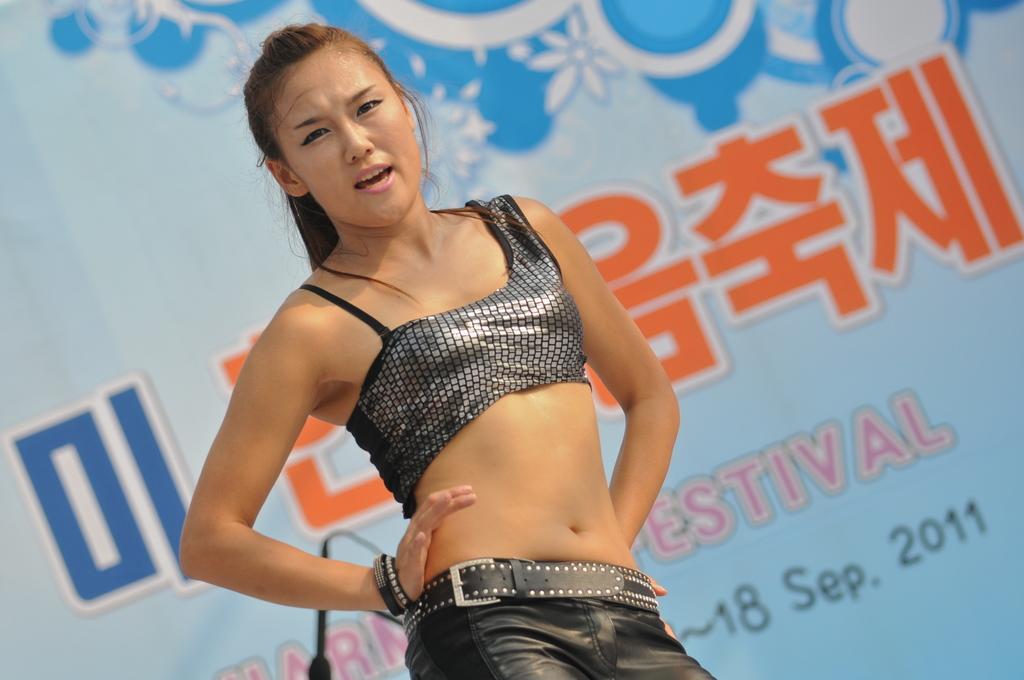Can you describe this image briefly? In the center of the image there is a girl. In the background of the image there is a banner. 